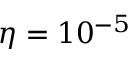Convert formula to latex. <formula><loc_0><loc_0><loc_500><loc_500>\eta = 1 0 ^ { - 5 }</formula> 